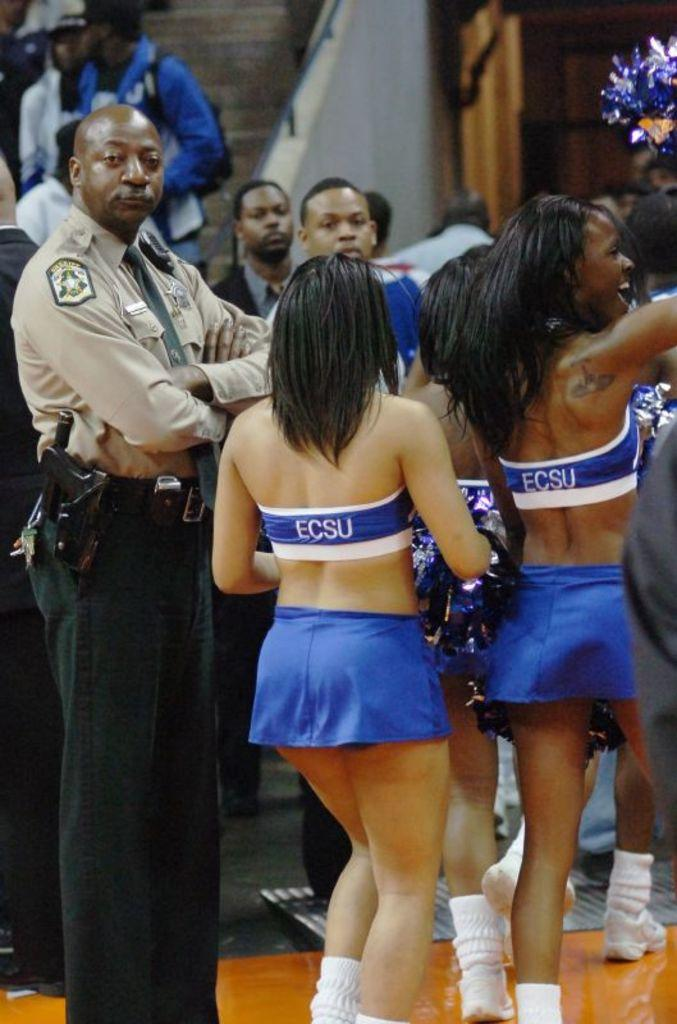<image>
Present a compact description of the photo's key features. Cheerleaders with ECSU on the backs of their tops are leaving the stadium. 